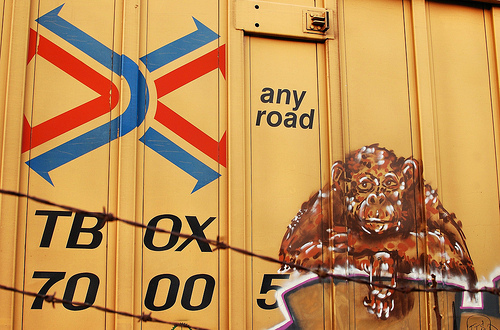<image>
Can you confirm if the monkey is in front of the shipping container? Yes. The monkey is positioned in front of the shipping container, appearing closer to the camera viewpoint. 